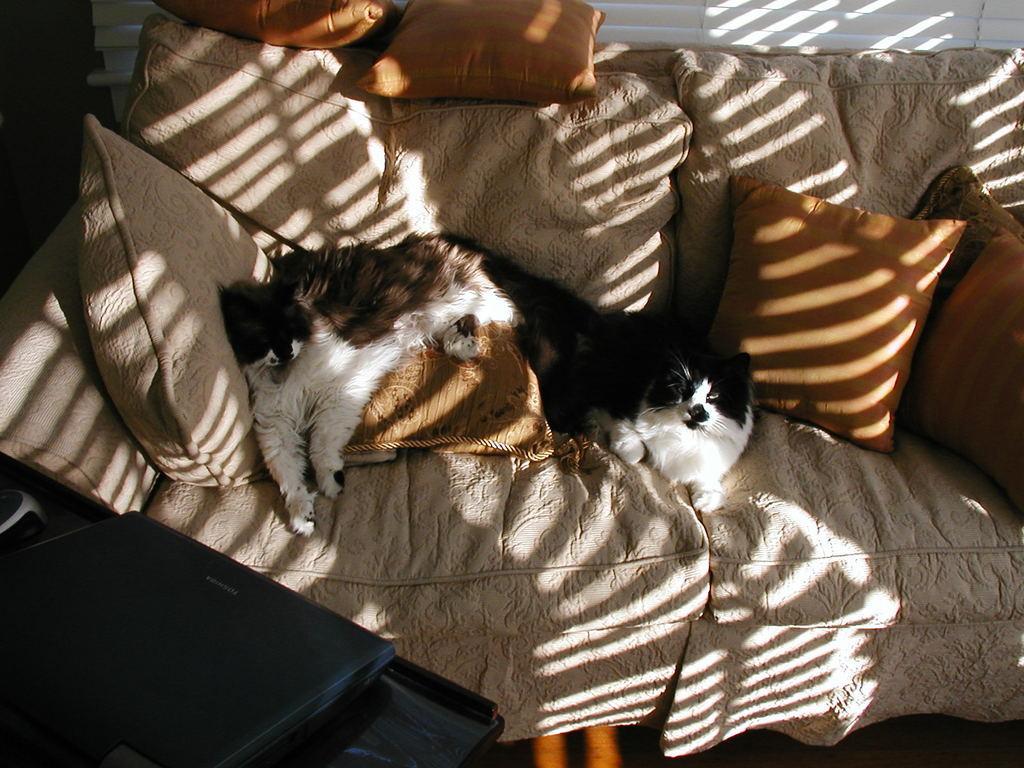How would you summarize this image in a sentence or two? In this image I can see 2 cats on a couch. There are cushions and a laptop at the front. 